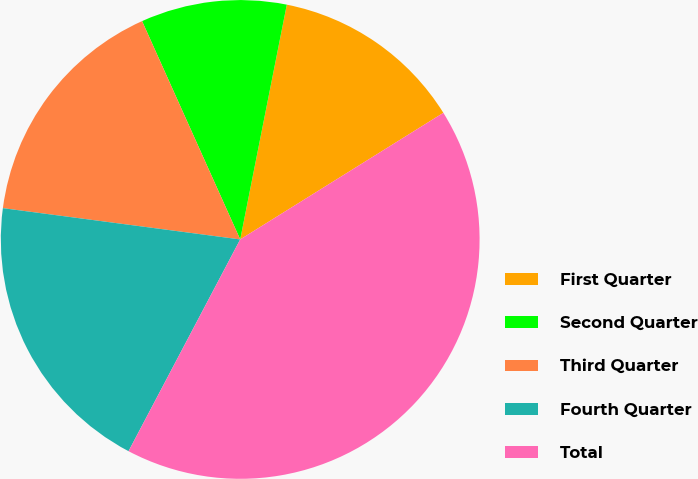Convert chart. <chart><loc_0><loc_0><loc_500><loc_500><pie_chart><fcel>First Quarter<fcel>Second Quarter<fcel>Third Quarter<fcel>Fourth Quarter<fcel>Total<nl><fcel>13.01%<fcel>9.84%<fcel>16.19%<fcel>19.36%<fcel>41.59%<nl></chart> 